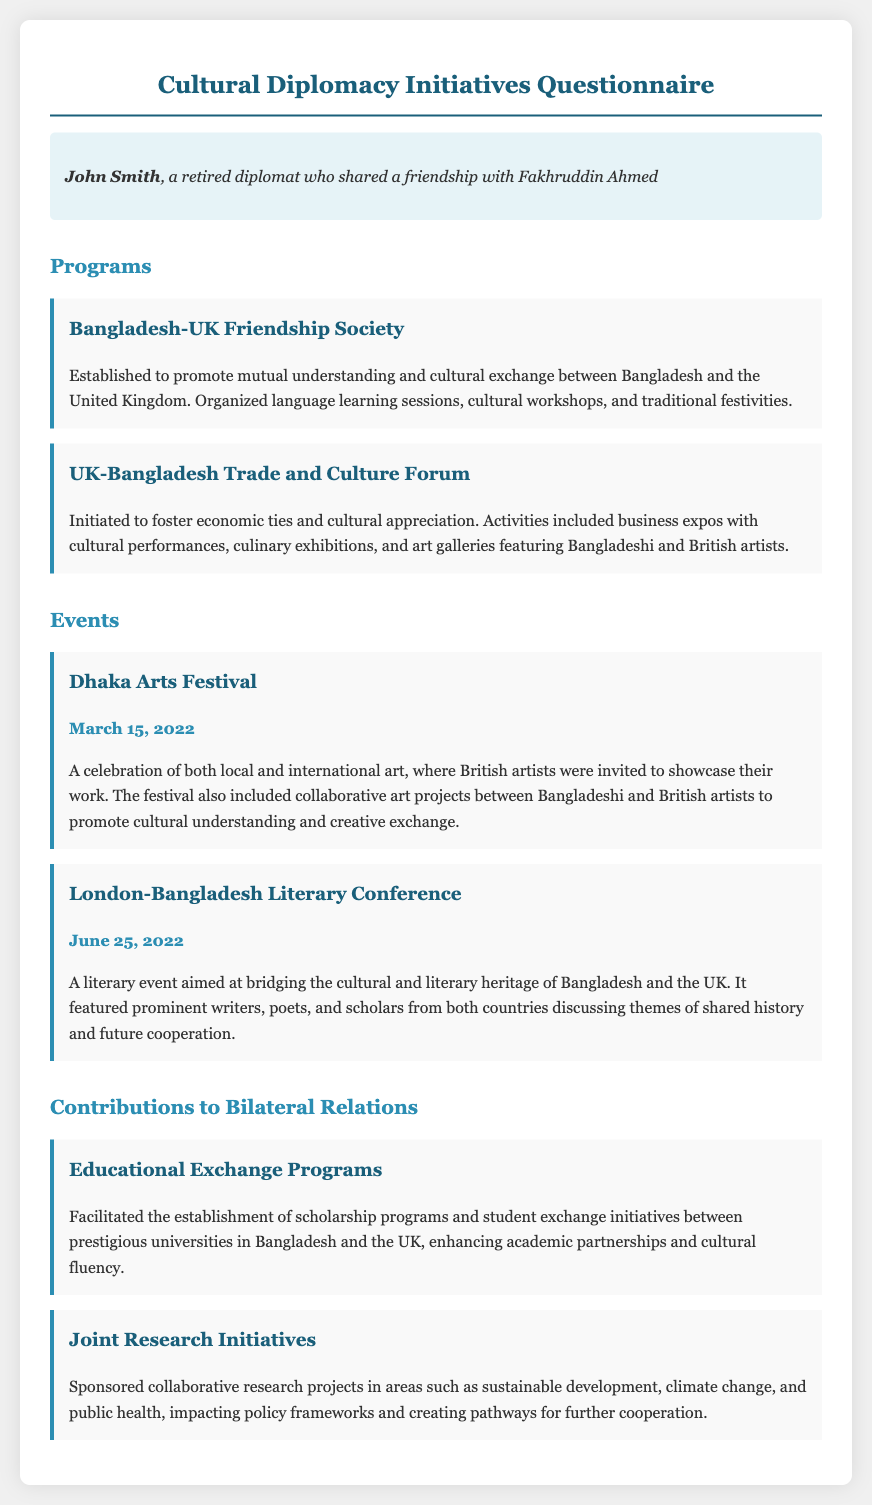what is the name of the first program mentioned? The first program listed is the Bangladesh-UK Friendship Society, which aims to promote mutual understanding and cultural exchange.
Answer: Bangladesh-UK Friendship Society what is the date of the Dhaka Arts Festival? The Dhaka Arts Festival took place on March 15, 2022.
Answer: March 15, 2022 what type of event is the London-Bangladesh Literary Conference? The London-Bangladesh Literary Conference is a literary event aimed at bridging cultural and literary heritage.
Answer: Literary event how many events are listed in the document? There are two events mentioned in the document, the Dhaka Arts Festival and the London-Bangladesh Literary Conference.
Answer: 2 what is the focus of the Joint Research Initiatives? The Joint Research Initiatives focus on areas such as sustainable development, climate change, and public health.
Answer: Sustainable development, climate change, public health what type of programs were established through Educational Exchange Programs? Educational Exchange Programs facilitated scholarship programs and student exchange initiatives between universities.
Answer: Scholarship programs and student exchange initiatives which two countries are primarily involved in the initiatives described? The initiatives described primarily involve Bangladesh and the United Kingdom.
Answer: Bangladesh and the United Kingdom what is one of the activities organized by the UK-Bangladesh Trade and Culture Forum? One of the activities organized was business expos with cultural performances.
Answer: Business expos with cultural performances 